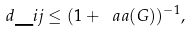Convert formula to latex. <formula><loc_0><loc_0><loc_500><loc_500>d \_ { i j } \leq ( 1 + \ a a ( G ) ) ^ { - 1 } ,</formula> 